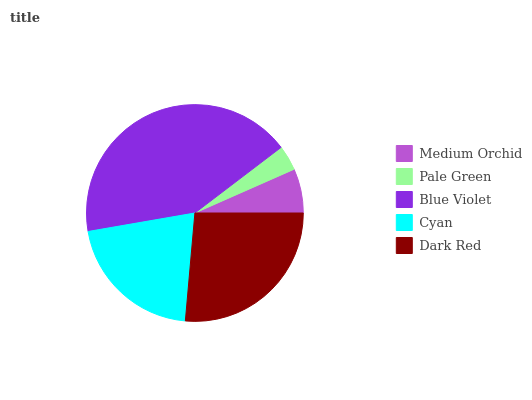Is Pale Green the minimum?
Answer yes or no. Yes. Is Blue Violet the maximum?
Answer yes or no. Yes. Is Blue Violet the minimum?
Answer yes or no. No. Is Pale Green the maximum?
Answer yes or no. No. Is Blue Violet greater than Pale Green?
Answer yes or no. Yes. Is Pale Green less than Blue Violet?
Answer yes or no. Yes. Is Pale Green greater than Blue Violet?
Answer yes or no. No. Is Blue Violet less than Pale Green?
Answer yes or no. No. Is Cyan the high median?
Answer yes or no. Yes. Is Cyan the low median?
Answer yes or no. Yes. Is Dark Red the high median?
Answer yes or no. No. Is Pale Green the low median?
Answer yes or no. No. 